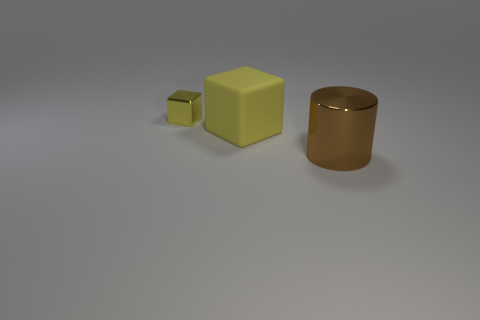Add 2 big yellow blocks. How many objects exist? 5 Subtract all cylinders. How many objects are left? 2 Add 1 large metallic cylinders. How many large metallic cylinders are left? 2 Add 3 brown metallic cylinders. How many brown metallic cylinders exist? 4 Subtract 1 brown cylinders. How many objects are left? 2 Subtract all cyan cubes. Subtract all purple spheres. How many cubes are left? 2 Subtract all large matte things. Subtract all blue cylinders. How many objects are left? 2 